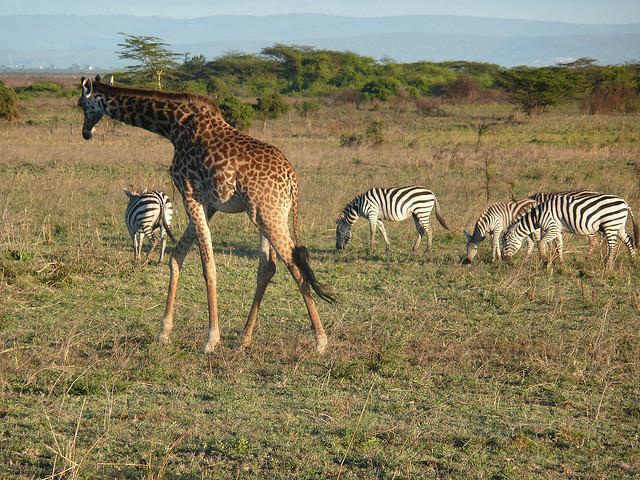How many zebras are in the photo?
Give a very brief answer. 4. 